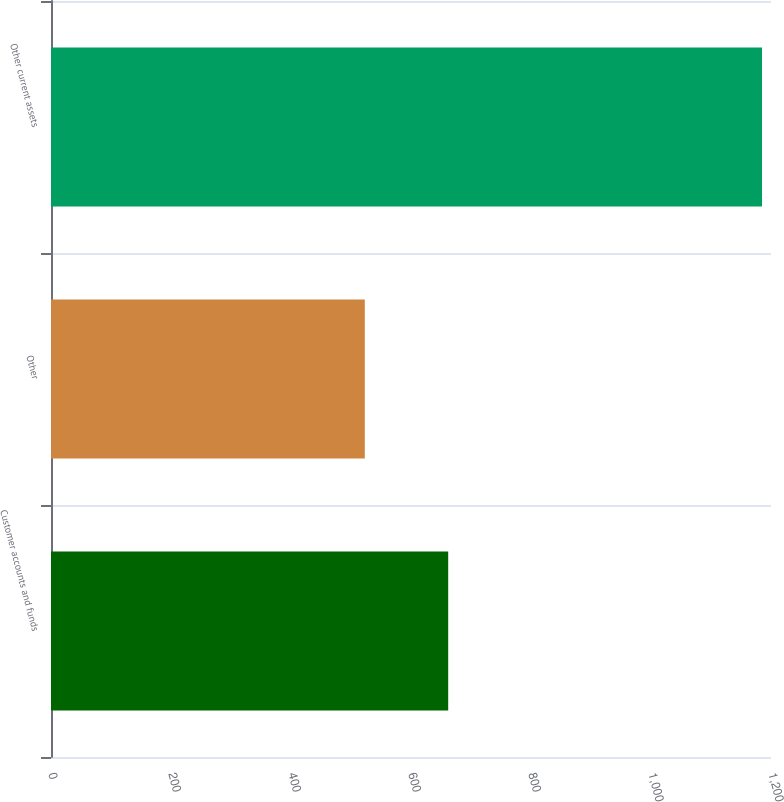<chart> <loc_0><loc_0><loc_500><loc_500><bar_chart><fcel>Customer accounts and funds<fcel>Other<fcel>Other current assets<nl><fcel>662<fcel>523<fcel>1185<nl></chart> 